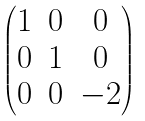<formula> <loc_0><loc_0><loc_500><loc_500>\begin{pmatrix} 1 & 0 & 0 \\ 0 & 1 & 0 \\ 0 & 0 & - 2 \end{pmatrix}</formula> 